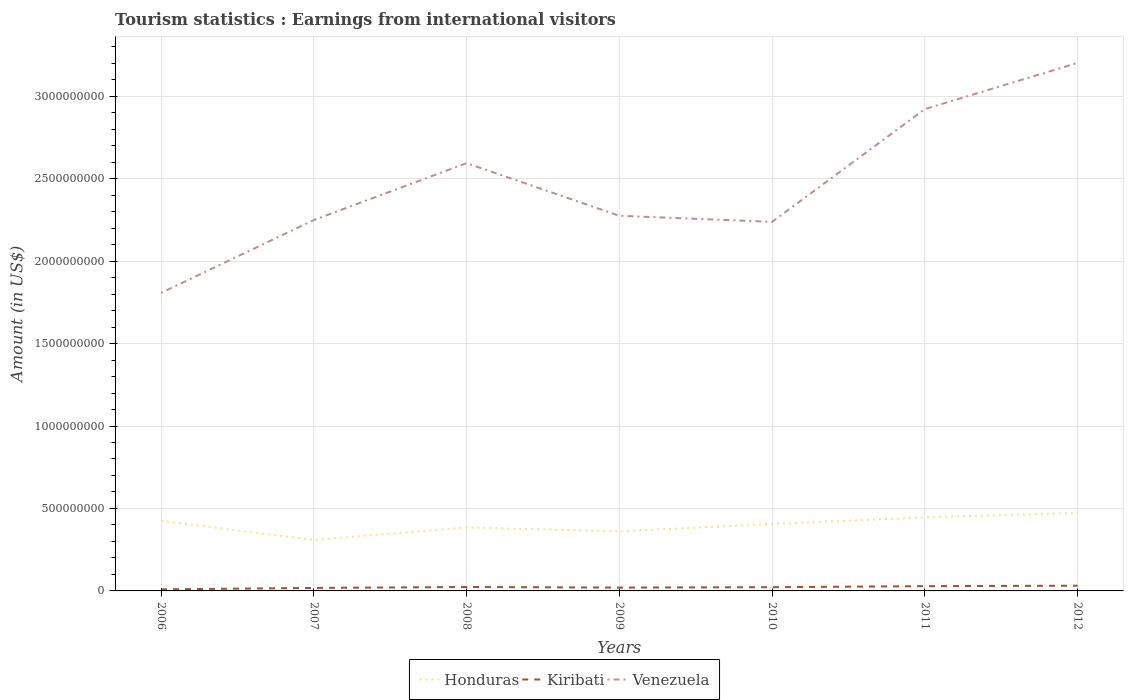How many different coloured lines are there?
Give a very brief answer. 3. Across all years, what is the maximum earnings from international visitors in Honduras?
Give a very brief answer. 3.09e+08. What is the total earnings from international visitors in Honduras in the graph?
Your answer should be compact. 2.40e+07. What is the difference between the highest and the second highest earnings from international visitors in Honduras?
Your answer should be very brief. 1.64e+08. How many lines are there?
Offer a terse response. 3. What is the difference between two consecutive major ticks on the Y-axis?
Give a very brief answer. 5.00e+08. How are the legend labels stacked?
Make the answer very short. Horizontal. What is the title of the graph?
Offer a terse response. Tourism statistics : Earnings from international visitors. What is the label or title of the X-axis?
Offer a very short reply. Years. What is the label or title of the Y-axis?
Provide a succinct answer. Amount (in US$). What is the Amount (in US$) of Honduras in 2006?
Keep it short and to the point. 4.25e+08. What is the Amount (in US$) in Kiribati in 2006?
Give a very brief answer. 9.60e+06. What is the Amount (in US$) in Venezuela in 2006?
Your response must be concise. 1.81e+09. What is the Amount (in US$) in Honduras in 2007?
Provide a succinct answer. 3.09e+08. What is the Amount (in US$) in Kiribati in 2007?
Keep it short and to the point. 1.81e+07. What is the Amount (in US$) of Venezuela in 2007?
Offer a terse response. 2.25e+09. What is the Amount (in US$) in Honduras in 2008?
Make the answer very short. 3.85e+08. What is the Amount (in US$) in Kiribati in 2008?
Offer a very short reply. 2.38e+07. What is the Amount (in US$) of Venezuela in 2008?
Offer a terse response. 2.59e+09. What is the Amount (in US$) of Honduras in 2009?
Give a very brief answer. 3.61e+08. What is the Amount (in US$) of Kiribati in 2009?
Give a very brief answer. 2.02e+07. What is the Amount (in US$) of Venezuela in 2009?
Your response must be concise. 2.28e+09. What is the Amount (in US$) of Honduras in 2010?
Provide a succinct answer. 4.06e+08. What is the Amount (in US$) in Kiribati in 2010?
Make the answer very short. 2.26e+07. What is the Amount (in US$) of Venezuela in 2010?
Give a very brief answer. 2.24e+09. What is the Amount (in US$) in Honduras in 2011?
Make the answer very short. 4.46e+08. What is the Amount (in US$) of Kiribati in 2011?
Offer a terse response. 2.90e+07. What is the Amount (in US$) of Venezuela in 2011?
Offer a terse response. 2.92e+09. What is the Amount (in US$) in Honduras in 2012?
Make the answer very short. 4.73e+08. What is the Amount (in US$) in Kiribati in 2012?
Your answer should be compact. 3.16e+07. What is the Amount (in US$) of Venezuela in 2012?
Offer a terse response. 3.20e+09. Across all years, what is the maximum Amount (in US$) in Honduras?
Provide a succinct answer. 4.73e+08. Across all years, what is the maximum Amount (in US$) in Kiribati?
Your answer should be compact. 3.16e+07. Across all years, what is the maximum Amount (in US$) in Venezuela?
Offer a very short reply. 3.20e+09. Across all years, what is the minimum Amount (in US$) of Honduras?
Your answer should be very brief. 3.09e+08. Across all years, what is the minimum Amount (in US$) in Kiribati?
Offer a terse response. 9.60e+06. Across all years, what is the minimum Amount (in US$) in Venezuela?
Your response must be concise. 1.81e+09. What is the total Amount (in US$) of Honduras in the graph?
Make the answer very short. 2.80e+09. What is the total Amount (in US$) of Kiribati in the graph?
Your answer should be very brief. 1.55e+08. What is the total Amount (in US$) of Venezuela in the graph?
Keep it short and to the point. 1.73e+1. What is the difference between the Amount (in US$) of Honduras in 2006 and that in 2007?
Make the answer very short. 1.16e+08. What is the difference between the Amount (in US$) of Kiribati in 2006 and that in 2007?
Keep it short and to the point. -8.50e+06. What is the difference between the Amount (in US$) of Venezuela in 2006 and that in 2007?
Your response must be concise. -4.42e+08. What is the difference between the Amount (in US$) in Honduras in 2006 and that in 2008?
Your response must be concise. 4.00e+07. What is the difference between the Amount (in US$) of Kiribati in 2006 and that in 2008?
Your response must be concise. -1.42e+07. What is the difference between the Amount (in US$) of Venezuela in 2006 and that in 2008?
Your answer should be very brief. -7.87e+08. What is the difference between the Amount (in US$) in Honduras in 2006 and that in 2009?
Make the answer very short. 6.40e+07. What is the difference between the Amount (in US$) of Kiribati in 2006 and that in 2009?
Your response must be concise. -1.06e+07. What is the difference between the Amount (in US$) in Venezuela in 2006 and that in 2009?
Give a very brief answer. -4.68e+08. What is the difference between the Amount (in US$) in Honduras in 2006 and that in 2010?
Ensure brevity in your answer.  1.90e+07. What is the difference between the Amount (in US$) of Kiribati in 2006 and that in 2010?
Make the answer very short. -1.30e+07. What is the difference between the Amount (in US$) of Venezuela in 2006 and that in 2010?
Offer a very short reply. -4.31e+08. What is the difference between the Amount (in US$) in Honduras in 2006 and that in 2011?
Offer a very short reply. -2.10e+07. What is the difference between the Amount (in US$) in Kiribati in 2006 and that in 2011?
Ensure brevity in your answer.  -1.94e+07. What is the difference between the Amount (in US$) of Venezuela in 2006 and that in 2011?
Ensure brevity in your answer.  -1.12e+09. What is the difference between the Amount (in US$) in Honduras in 2006 and that in 2012?
Provide a succinct answer. -4.80e+07. What is the difference between the Amount (in US$) in Kiribati in 2006 and that in 2012?
Keep it short and to the point. -2.20e+07. What is the difference between the Amount (in US$) of Venezuela in 2006 and that in 2012?
Provide a short and direct response. -1.40e+09. What is the difference between the Amount (in US$) in Honduras in 2007 and that in 2008?
Provide a succinct answer. -7.60e+07. What is the difference between the Amount (in US$) of Kiribati in 2007 and that in 2008?
Ensure brevity in your answer.  -5.70e+06. What is the difference between the Amount (in US$) in Venezuela in 2007 and that in 2008?
Offer a very short reply. -3.45e+08. What is the difference between the Amount (in US$) in Honduras in 2007 and that in 2009?
Make the answer very short. -5.20e+07. What is the difference between the Amount (in US$) in Kiribati in 2007 and that in 2009?
Your response must be concise. -2.10e+06. What is the difference between the Amount (in US$) in Venezuela in 2007 and that in 2009?
Make the answer very short. -2.60e+07. What is the difference between the Amount (in US$) of Honduras in 2007 and that in 2010?
Give a very brief answer. -9.70e+07. What is the difference between the Amount (in US$) in Kiribati in 2007 and that in 2010?
Your answer should be very brief. -4.50e+06. What is the difference between the Amount (in US$) in Venezuela in 2007 and that in 2010?
Ensure brevity in your answer.  1.10e+07. What is the difference between the Amount (in US$) of Honduras in 2007 and that in 2011?
Your answer should be very brief. -1.37e+08. What is the difference between the Amount (in US$) in Kiribati in 2007 and that in 2011?
Your response must be concise. -1.09e+07. What is the difference between the Amount (in US$) of Venezuela in 2007 and that in 2011?
Offer a very short reply. -6.73e+08. What is the difference between the Amount (in US$) of Honduras in 2007 and that in 2012?
Keep it short and to the point. -1.64e+08. What is the difference between the Amount (in US$) of Kiribati in 2007 and that in 2012?
Give a very brief answer. -1.35e+07. What is the difference between the Amount (in US$) of Venezuela in 2007 and that in 2012?
Keep it short and to the point. -9.53e+08. What is the difference between the Amount (in US$) of Honduras in 2008 and that in 2009?
Give a very brief answer. 2.40e+07. What is the difference between the Amount (in US$) of Kiribati in 2008 and that in 2009?
Provide a succinct answer. 3.60e+06. What is the difference between the Amount (in US$) of Venezuela in 2008 and that in 2009?
Give a very brief answer. 3.19e+08. What is the difference between the Amount (in US$) of Honduras in 2008 and that in 2010?
Provide a short and direct response. -2.10e+07. What is the difference between the Amount (in US$) of Kiribati in 2008 and that in 2010?
Offer a terse response. 1.20e+06. What is the difference between the Amount (in US$) of Venezuela in 2008 and that in 2010?
Make the answer very short. 3.56e+08. What is the difference between the Amount (in US$) of Honduras in 2008 and that in 2011?
Your response must be concise. -6.10e+07. What is the difference between the Amount (in US$) of Kiribati in 2008 and that in 2011?
Offer a very short reply. -5.20e+06. What is the difference between the Amount (in US$) of Venezuela in 2008 and that in 2011?
Offer a very short reply. -3.28e+08. What is the difference between the Amount (in US$) in Honduras in 2008 and that in 2012?
Provide a succinct answer. -8.80e+07. What is the difference between the Amount (in US$) in Kiribati in 2008 and that in 2012?
Your answer should be compact. -7.80e+06. What is the difference between the Amount (in US$) of Venezuela in 2008 and that in 2012?
Your response must be concise. -6.08e+08. What is the difference between the Amount (in US$) of Honduras in 2009 and that in 2010?
Provide a short and direct response. -4.50e+07. What is the difference between the Amount (in US$) of Kiribati in 2009 and that in 2010?
Ensure brevity in your answer.  -2.40e+06. What is the difference between the Amount (in US$) in Venezuela in 2009 and that in 2010?
Give a very brief answer. 3.70e+07. What is the difference between the Amount (in US$) of Honduras in 2009 and that in 2011?
Provide a short and direct response. -8.50e+07. What is the difference between the Amount (in US$) of Kiribati in 2009 and that in 2011?
Offer a very short reply. -8.80e+06. What is the difference between the Amount (in US$) of Venezuela in 2009 and that in 2011?
Keep it short and to the point. -6.47e+08. What is the difference between the Amount (in US$) in Honduras in 2009 and that in 2012?
Offer a terse response. -1.12e+08. What is the difference between the Amount (in US$) in Kiribati in 2009 and that in 2012?
Your answer should be compact. -1.14e+07. What is the difference between the Amount (in US$) in Venezuela in 2009 and that in 2012?
Ensure brevity in your answer.  -9.27e+08. What is the difference between the Amount (in US$) of Honduras in 2010 and that in 2011?
Ensure brevity in your answer.  -4.00e+07. What is the difference between the Amount (in US$) of Kiribati in 2010 and that in 2011?
Offer a terse response. -6.40e+06. What is the difference between the Amount (in US$) in Venezuela in 2010 and that in 2011?
Provide a succinct answer. -6.84e+08. What is the difference between the Amount (in US$) of Honduras in 2010 and that in 2012?
Your answer should be very brief. -6.70e+07. What is the difference between the Amount (in US$) in Kiribati in 2010 and that in 2012?
Keep it short and to the point. -9.00e+06. What is the difference between the Amount (in US$) in Venezuela in 2010 and that in 2012?
Keep it short and to the point. -9.64e+08. What is the difference between the Amount (in US$) in Honduras in 2011 and that in 2012?
Make the answer very short. -2.70e+07. What is the difference between the Amount (in US$) of Kiribati in 2011 and that in 2012?
Your answer should be compact. -2.60e+06. What is the difference between the Amount (in US$) of Venezuela in 2011 and that in 2012?
Offer a very short reply. -2.80e+08. What is the difference between the Amount (in US$) of Honduras in 2006 and the Amount (in US$) of Kiribati in 2007?
Provide a succinct answer. 4.07e+08. What is the difference between the Amount (in US$) of Honduras in 2006 and the Amount (in US$) of Venezuela in 2007?
Your answer should be compact. -1.82e+09. What is the difference between the Amount (in US$) of Kiribati in 2006 and the Amount (in US$) of Venezuela in 2007?
Provide a short and direct response. -2.24e+09. What is the difference between the Amount (in US$) in Honduras in 2006 and the Amount (in US$) in Kiribati in 2008?
Provide a succinct answer. 4.01e+08. What is the difference between the Amount (in US$) in Honduras in 2006 and the Amount (in US$) in Venezuela in 2008?
Provide a succinct answer. -2.17e+09. What is the difference between the Amount (in US$) in Kiribati in 2006 and the Amount (in US$) in Venezuela in 2008?
Provide a short and direct response. -2.58e+09. What is the difference between the Amount (in US$) of Honduras in 2006 and the Amount (in US$) of Kiribati in 2009?
Your answer should be compact. 4.05e+08. What is the difference between the Amount (in US$) in Honduras in 2006 and the Amount (in US$) in Venezuela in 2009?
Your answer should be very brief. -1.85e+09. What is the difference between the Amount (in US$) in Kiribati in 2006 and the Amount (in US$) in Venezuela in 2009?
Make the answer very short. -2.27e+09. What is the difference between the Amount (in US$) of Honduras in 2006 and the Amount (in US$) of Kiribati in 2010?
Give a very brief answer. 4.02e+08. What is the difference between the Amount (in US$) in Honduras in 2006 and the Amount (in US$) in Venezuela in 2010?
Your answer should be very brief. -1.81e+09. What is the difference between the Amount (in US$) in Kiribati in 2006 and the Amount (in US$) in Venezuela in 2010?
Provide a succinct answer. -2.23e+09. What is the difference between the Amount (in US$) in Honduras in 2006 and the Amount (in US$) in Kiribati in 2011?
Offer a terse response. 3.96e+08. What is the difference between the Amount (in US$) in Honduras in 2006 and the Amount (in US$) in Venezuela in 2011?
Keep it short and to the point. -2.50e+09. What is the difference between the Amount (in US$) in Kiribati in 2006 and the Amount (in US$) in Venezuela in 2011?
Offer a very short reply. -2.91e+09. What is the difference between the Amount (in US$) of Honduras in 2006 and the Amount (in US$) of Kiribati in 2012?
Offer a terse response. 3.93e+08. What is the difference between the Amount (in US$) of Honduras in 2006 and the Amount (in US$) of Venezuela in 2012?
Provide a short and direct response. -2.78e+09. What is the difference between the Amount (in US$) of Kiribati in 2006 and the Amount (in US$) of Venezuela in 2012?
Keep it short and to the point. -3.19e+09. What is the difference between the Amount (in US$) in Honduras in 2007 and the Amount (in US$) in Kiribati in 2008?
Provide a short and direct response. 2.85e+08. What is the difference between the Amount (in US$) of Honduras in 2007 and the Amount (in US$) of Venezuela in 2008?
Offer a terse response. -2.28e+09. What is the difference between the Amount (in US$) of Kiribati in 2007 and the Amount (in US$) of Venezuela in 2008?
Keep it short and to the point. -2.58e+09. What is the difference between the Amount (in US$) in Honduras in 2007 and the Amount (in US$) in Kiribati in 2009?
Keep it short and to the point. 2.89e+08. What is the difference between the Amount (in US$) of Honduras in 2007 and the Amount (in US$) of Venezuela in 2009?
Ensure brevity in your answer.  -1.97e+09. What is the difference between the Amount (in US$) of Kiribati in 2007 and the Amount (in US$) of Venezuela in 2009?
Ensure brevity in your answer.  -2.26e+09. What is the difference between the Amount (in US$) in Honduras in 2007 and the Amount (in US$) in Kiribati in 2010?
Your answer should be very brief. 2.86e+08. What is the difference between the Amount (in US$) of Honduras in 2007 and the Amount (in US$) of Venezuela in 2010?
Give a very brief answer. -1.93e+09. What is the difference between the Amount (in US$) in Kiribati in 2007 and the Amount (in US$) in Venezuela in 2010?
Ensure brevity in your answer.  -2.22e+09. What is the difference between the Amount (in US$) in Honduras in 2007 and the Amount (in US$) in Kiribati in 2011?
Your answer should be compact. 2.80e+08. What is the difference between the Amount (in US$) of Honduras in 2007 and the Amount (in US$) of Venezuela in 2011?
Give a very brief answer. -2.61e+09. What is the difference between the Amount (in US$) in Kiribati in 2007 and the Amount (in US$) in Venezuela in 2011?
Your answer should be very brief. -2.90e+09. What is the difference between the Amount (in US$) of Honduras in 2007 and the Amount (in US$) of Kiribati in 2012?
Keep it short and to the point. 2.77e+08. What is the difference between the Amount (in US$) of Honduras in 2007 and the Amount (in US$) of Venezuela in 2012?
Offer a very short reply. -2.89e+09. What is the difference between the Amount (in US$) in Kiribati in 2007 and the Amount (in US$) in Venezuela in 2012?
Provide a short and direct response. -3.18e+09. What is the difference between the Amount (in US$) of Honduras in 2008 and the Amount (in US$) of Kiribati in 2009?
Keep it short and to the point. 3.65e+08. What is the difference between the Amount (in US$) in Honduras in 2008 and the Amount (in US$) in Venezuela in 2009?
Your answer should be very brief. -1.89e+09. What is the difference between the Amount (in US$) of Kiribati in 2008 and the Amount (in US$) of Venezuela in 2009?
Keep it short and to the point. -2.25e+09. What is the difference between the Amount (in US$) of Honduras in 2008 and the Amount (in US$) of Kiribati in 2010?
Give a very brief answer. 3.62e+08. What is the difference between the Amount (in US$) of Honduras in 2008 and the Amount (in US$) of Venezuela in 2010?
Give a very brief answer. -1.85e+09. What is the difference between the Amount (in US$) of Kiribati in 2008 and the Amount (in US$) of Venezuela in 2010?
Provide a succinct answer. -2.21e+09. What is the difference between the Amount (in US$) of Honduras in 2008 and the Amount (in US$) of Kiribati in 2011?
Make the answer very short. 3.56e+08. What is the difference between the Amount (in US$) of Honduras in 2008 and the Amount (in US$) of Venezuela in 2011?
Keep it short and to the point. -2.54e+09. What is the difference between the Amount (in US$) of Kiribati in 2008 and the Amount (in US$) of Venezuela in 2011?
Provide a short and direct response. -2.90e+09. What is the difference between the Amount (in US$) in Honduras in 2008 and the Amount (in US$) in Kiribati in 2012?
Your response must be concise. 3.53e+08. What is the difference between the Amount (in US$) in Honduras in 2008 and the Amount (in US$) in Venezuela in 2012?
Offer a very short reply. -2.82e+09. What is the difference between the Amount (in US$) in Kiribati in 2008 and the Amount (in US$) in Venezuela in 2012?
Ensure brevity in your answer.  -3.18e+09. What is the difference between the Amount (in US$) of Honduras in 2009 and the Amount (in US$) of Kiribati in 2010?
Make the answer very short. 3.38e+08. What is the difference between the Amount (in US$) in Honduras in 2009 and the Amount (in US$) in Venezuela in 2010?
Your response must be concise. -1.88e+09. What is the difference between the Amount (in US$) in Kiribati in 2009 and the Amount (in US$) in Venezuela in 2010?
Provide a succinct answer. -2.22e+09. What is the difference between the Amount (in US$) in Honduras in 2009 and the Amount (in US$) in Kiribati in 2011?
Keep it short and to the point. 3.32e+08. What is the difference between the Amount (in US$) in Honduras in 2009 and the Amount (in US$) in Venezuela in 2011?
Your response must be concise. -2.56e+09. What is the difference between the Amount (in US$) of Kiribati in 2009 and the Amount (in US$) of Venezuela in 2011?
Keep it short and to the point. -2.90e+09. What is the difference between the Amount (in US$) in Honduras in 2009 and the Amount (in US$) in Kiribati in 2012?
Make the answer very short. 3.29e+08. What is the difference between the Amount (in US$) in Honduras in 2009 and the Amount (in US$) in Venezuela in 2012?
Your answer should be compact. -2.84e+09. What is the difference between the Amount (in US$) in Kiribati in 2009 and the Amount (in US$) in Venezuela in 2012?
Keep it short and to the point. -3.18e+09. What is the difference between the Amount (in US$) in Honduras in 2010 and the Amount (in US$) in Kiribati in 2011?
Make the answer very short. 3.77e+08. What is the difference between the Amount (in US$) in Honduras in 2010 and the Amount (in US$) in Venezuela in 2011?
Your answer should be compact. -2.52e+09. What is the difference between the Amount (in US$) of Kiribati in 2010 and the Amount (in US$) of Venezuela in 2011?
Keep it short and to the point. -2.90e+09. What is the difference between the Amount (in US$) of Honduras in 2010 and the Amount (in US$) of Kiribati in 2012?
Your answer should be very brief. 3.74e+08. What is the difference between the Amount (in US$) of Honduras in 2010 and the Amount (in US$) of Venezuela in 2012?
Provide a succinct answer. -2.80e+09. What is the difference between the Amount (in US$) of Kiribati in 2010 and the Amount (in US$) of Venezuela in 2012?
Your answer should be very brief. -3.18e+09. What is the difference between the Amount (in US$) of Honduras in 2011 and the Amount (in US$) of Kiribati in 2012?
Make the answer very short. 4.14e+08. What is the difference between the Amount (in US$) in Honduras in 2011 and the Amount (in US$) in Venezuela in 2012?
Provide a short and direct response. -2.76e+09. What is the difference between the Amount (in US$) of Kiribati in 2011 and the Amount (in US$) of Venezuela in 2012?
Offer a terse response. -3.17e+09. What is the average Amount (in US$) of Honduras per year?
Offer a terse response. 4.01e+08. What is the average Amount (in US$) in Kiribati per year?
Provide a short and direct response. 2.21e+07. What is the average Amount (in US$) of Venezuela per year?
Provide a succinct answer. 2.47e+09. In the year 2006, what is the difference between the Amount (in US$) of Honduras and Amount (in US$) of Kiribati?
Your answer should be very brief. 4.15e+08. In the year 2006, what is the difference between the Amount (in US$) of Honduras and Amount (in US$) of Venezuela?
Ensure brevity in your answer.  -1.38e+09. In the year 2006, what is the difference between the Amount (in US$) in Kiribati and Amount (in US$) in Venezuela?
Offer a terse response. -1.80e+09. In the year 2007, what is the difference between the Amount (in US$) in Honduras and Amount (in US$) in Kiribati?
Your answer should be compact. 2.91e+08. In the year 2007, what is the difference between the Amount (in US$) in Honduras and Amount (in US$) in Venezuela?
Give a very brief answer. -1.94e+09. In the year 2007, what is the difference between the Amount (in US$) of Kiribati and Amount (in US$) of Venezuela?
Keep it short and to the point. -2.23e+09. In the year 2008, what is the difference between the Amount (in US$) of Honduras and Amount (in US$) of Kiribati?
Provide a succinct answer. 3.61e+08. In the year 2008, what is the difference between the Amount (in US$) of Honduras and Amount (in US$) of Venezuela?
Your response must be concise. -2.21e+09. In the year 2008, what is the difference between the Amount (in US$) of Kiribati and Amount (in US$) of Venezuela?
Ensure brevity in your answer.  -2.57e+09. In the year 2009, what is the difference between the Amount (in US$) of Honduras and Amount (in US$) of Kiribati?
Ensure brevity in your answer.  3.41e+08. In the year 2009, what is the difference between the Amount (in US$) in Honduras and Amount (in US$) in Venezuela?
Your response must be concise. -1.91e+09. In the year 2009, what is the difference between the Amount (in US$) in Kiribati and Amount (in US$) in Venezuela?
Make the answer very short. -2.25e+09. In the year 2010, what is the difference between the Amount (in US$) of Honduras and Amount (in US$) of Kiribati?
Offer a very short reply. 3.83e+08. In the year 2010, what is the difference between the Amount (in US$) in Honduras and Amount (in US$) in Venezuela?
Offer a terse response. -1.83e+09. In the year 2010, what is the difference between the Amount (in US$) in Kiribati and Amount (in US$) in Venezuela?
Your response must be concise. -2.22e+09. In the year 2011, what is the difference between the Amount (in US$) of Honduras and Amount (in US$) of Kiribati?
Provide a succinct answer. 4.17e+08. In the year 2011, what is the difference between the Amount (in US$) in Honduras and Amount (in US$) in Venezuela?
Keep it short and to the point. -2.48e+09. In the year 2011, what is the difference between the Amount (in US$) in Kiribati and Amount (in US$) in Venezuela?
Keep it short and to the point. -2.89e+09. In the year 2012, what is the difference between the Amount (in US$) in Honduras and Amount (in US$) in Kiribati?
Keep it short and to the point. 4.41e+08. In the year 2012, what is the difference between the Amount (in US$) of Honduras and Amount (in US$) of Venezuela?
Your answer should be compact. -2.73e+09. In the year 2012, what is the difference between the Amount (in US$) of Kiribati and Amount (in US$) of Venezuela?
Make the answer very short. -3.17e+09. What is the ratio of the Amount (in US$) of Honduras in 2006 to that in 2007?
Offer a terse response. 1.38. What is the ratio of the Amount (in US$) of Kiribati in 2006 to that in 2007?
Offer a terse response. 0.53. What is the ratio of the Amount (in US$) in Venezuela in 2006 to that in 2007?
Your answer should be very brief. 0.8. What is the ratio of the Amount (in US$) in Honduras in 2006 to that in 2008?
Your answer should be compact. 1.1. What is the ratio of the Amount (in US$) in Kiribati in 2006 to that in 2008?
Offer a very short reply. 0.4. What is the ratio of the Amount (in US$) of Venezuela in 2006 to that in 2008?
Your answer should be very brief. 0.7. What is the ratio of the Amount (in US$) in Honduras in 2006 to that in 2009?
Provide a succinct answer. 1.18. What is the ratio of the Amount (in US$) in Kiribati in 2006 to that in 2009?
Give a very brief answer. 0.48. What is the ratio of the Amount (in US$) of Venezuela in 2006 to that in 2009?
Your answer should be compact. 0.79. What is the ratio of the Amount (in US$) in Honduras in 2006 to that in 2010?
Your response must be concise. 1.05. What is the ratio of the Amount (in US$) in Kiribati in 2006 to that in 2010?
Ensure brevity in your answer.  0.42. What is the ratio of the Amount (in US$) in Venezuela in 2006 to that in 2010?
Provide a short and direct response. 0.81. What is the ratio of the Amount (in US$) of Honduras in 2006 to that in 2011?
Your answer should be very brief. 0.95. What is the ratio of the Amount (in US$) of Kiribati in 2006 to that in 2011?
Offer a terse response. 0.33. What is the ratio of the Amount (in US$) of Venezuela in 2006 to that in 2011?
Make the answer very short. 0.62. What is the ratio of the Amount (in US$) of Honduras in 2006 to that in 2012?
Your response must be concise. 0.9. What is the ratio of the Amount (in US$) of Kiribati in 2006 to that in 2012?
Offer a terse response. 0.3. What is the ratio of the Amount (in US$) of Venezuela in 2006 to that in 2012?
Your answer should be compact. 0.56. What is the ratio of the Amount (in US$) of Honduras in 2007 to that in 2008?
Your response must be concise. 0.8. What is the ratio of the Amount (in US$) in Kiribati in 2007 to that in 2008?
Offer a terse response. 0.76. What is the ratio of the Amount (in US$) of Venezuela in 2007 to that in 2008?
Make the answer very short. 0.87. What is the ratio of the Amount (in US$) of Honduras in 2007 to that in 2009?
Ensure brevity in your answer.  0.86. What is the ratio of the Amount (in US$) in Kiribati in 2007 to that in 2009?
Offer a very short reply. 0.9. What is the ratio of the Amount (in US$) of Venezuela in 2007 to that in 2009?
Your response must be concise. 0.99. What is the ratio of the Amount (in US$) in Honduras in 2007 to that in 2010?
Provide a short and direct response. 0.76. What is the ratio of the Amount (in US$) in Kiribati in 2007 to that in 2010?
Ensure brevity in your answer.  0.8. What is the ratio of the Amount (in US$) of Venezuela in 2007 to that in 2010?
Provide a succinct answer. 1. What is the ratio of the Amount (in US$) in Honduras in 2007 to that in 2011?
Provide a short and direct response. 0.69. What is the ratio of the Amount (in US$) in Kiribati in 2007 to that in 2011?
Offer a terse response. 0.62. What is the ratio of the Amount (in US$) in Venezuela in 2007 to that in 2011?
Offer a very short reply. 0.77. What is the ratio of the Amount (in US$) of Honduras in 2007 to that in 2012?
Ensure brevity in your answer.  0.65. What is the ratio of the Amount (in US$) of Kiribati in 2007 to that in 2012?
Your answer should be compact. 0.57. What is the ratio of the Amount (in US$) in Venezuela in 2007 to that in 2012?
Make the answer very short. 0.7. What is the ratio of the Amount (in US$) in Honduras in 2008 to that in 2009?
Your answer should be very brief. 1.07. What is the ratio of the Amount (in US$) of Kiribati in 2008 to that in 2009?
Provide a short and direct response. 1.18. What is the ratio of the Amount (in US$) in Venezuela in 2008 to that in 2009?
Your response must be concise. 1.14. What is the ratio of the Amount (in US$) in Honduras in 2008 to that in 2010?
Your response must be concise. 0.95. What is the ratio of the Amount (in US$) in Kiribati in 2008 to that in 2010?
Offer a very short reply. 1.05. What is the ratio of the Amount (in US$) in Venezuela in 2008 to that in 2010?
Ensure brevity in your answer.  1.16. What is the ratio of the Amount (in US$) of Honduras in 2008 to that in 2011?
Make the answer very short. 0.86. What is the ratio of the Amount (in US$) of Kiribati in 2008 to that in 2011?
Give a very brief answer. 0.82. What is the ratio of the Amount (in US$) in Venezuela in 2008 to that in 2011?
Your answer should be very brief. 0.89. What is the ratio of the Amount (in US$) in Honduras in 2008 to that in 2012?
Provide a short and direct response. 0.81. What is the ratio of the Amount (in US$) of Kiribati in 2008 to that in 2012?
Offer a very short reply. 0.75. What is the ratio of the Amount (in US$) of Venezuela in 2008 to that in 2012?
Keep it short and to the point. 0.81. What is the ratio of the Amount (in US$) of Honduras in 2009 to that in 2010?
Give a very brief answer. 0.89. What is the ratio of the Amount (in US$) in Kiribati in 2009 to that in 2010?
Make the answer very short. 0.89. What is the ratio of the Amount (in US$) in Venezuela in 2009 to that in 2010?
Provide a short and direct response. 1.02. What is the ratio of the Amount (in US$) in Honduras in 2009 to that in 2011?
Your answer should be compact. 0.81. What is the ratio of the Amount (in US$) of Kiribati in 2009 to that in 2011?
Your response must be concise. 0.7. What is the ratio of the Amount (in US$) in Venezuela in 2009 to that in 2011?
Ensure brevity in your answer.  0.78. What is the ratio of the Amount (in US$) in Honduras in 2009 to that in 2012?
Give a very brief answer. 0.76. What is the ratio of the Amount (in US$) in Kiribati in 2009 to that in 2012?
Keep it short and to the point. 0.64. What is the ratio of the Amount (in US$) of Venezuela in 2009 to that in 2012?
Make the answer very short. 0.71. What is the ratio of the Amount (in US$) in Honduras in 2010 to that in 2011?
Provide a succinct answer. 0.91. What is the ratio of the Amount (in US$) of Kiribati in 2010 to that in 2011?
Provide a short and direct response. 0.78. What is the ratio of the Amount (in US$) in Venezuela in 2010 to that in 2011?
Provide a short and direct response. 0.77. What is the ratio of the Amount (in US$) in Honduras in 2010 to that in 2012?
Give a very brief answer. 0.86. What is the ratio of the Amount (in US$) in Kiribati in 2010 to that in 2012?
Ensure brevity in your answer.  0.72. What is the ratio of the Amount (in US$) in Venezuela in 2010 to that in 2012?
Offer a very short reply. 0.7. What is the ratio of the Amount (in US$) in Honduras in 2011 to that in 2012?
Provide a succinct answer. 0.94. What is the ratio of the Amount (in US$) of Kiribati in 2011 to that in 2012?
Keep it short and to the point. 0.92. What is the ratio of the Amount (in US$) of Venezuela in 2011 to that in 2012?
Your answer should be compact. 0.91. What is the difference between the highest and the second highest Amount (in US$) in Honduras?
Ensure brevity in your answer.  2.70e+07. What is the difference between the highest and the second highest Amount (in US$) of Kiribati?
Your answer should be very brief. 2.60e+06. What is the difference between the highest and the second highest Amount (in US$) of Venezuela?
Keep it short and to the point. 2.80e+08. What is the difference between the highest and the lowest Amount (in US$) of Honduras?
Offer a terse response. 1.64e+08. What is the difference between the highest and the lowest Amount (in US$) in Kiribati?
Make the answer very short. 2.20e+07. What is the difference between the highest and the lowest Amount (in US$) in Venezuela?
Offer a very short reply. 1.40e+09. 